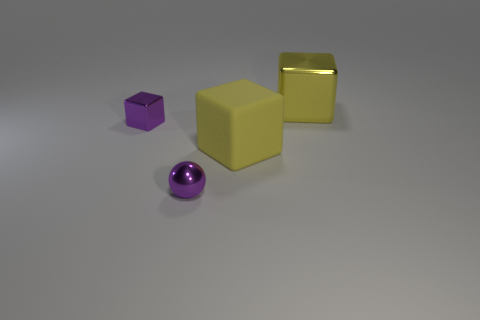How many tiny spheres are the same color as the tiny block?
Your response must be concise. 1. What material is the cube that is the same color as the large metal object?
Keep it short and to the point. Rubber. Are there any objects that are right of the tiny purple object that is in front of the yellow block that is in front of the tiny metallic cube?
Your answer should be compact. Yes. What number of metallic objects are gray balls or small spheres?
Provide a short and direct response. 1. Are there more big yellow metal things than tiny purple things?
Make the answer very short. No. What is the size of the yellow thing in front of the metallic cube to the right of the large yellow object that is in front of the yellow metal thing?
Your answer should be compact. Large. There is a metal cube that is to the left of the tiny purple metallic sphere; what is its size?
Offer a very short reply. Small. What number of objects are big yellow rubber blocks or shiny objects that are right of the big matte thing?
Your answer should be very brief. 2. What number of other things are there of the same size as the purple shiny ball?
Give a very brief answer. 1. What is the material of the other large yellow object that is the same shape as the big yellow rubber thing?
Provide a short and direct response. Metal. 